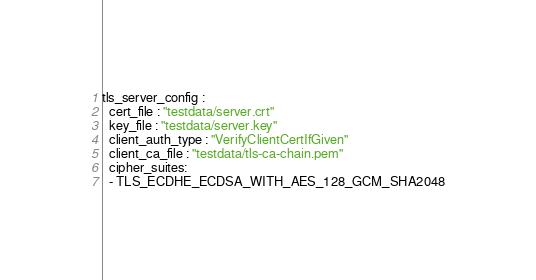<code> <loc_0><loc_0><loc_500><loc_500><_YAML_>tls_server_config :
  cert_file : "testdata/server.crt"
  key_file : "testdata/server.key"
  client_auth_type : "VerifyClientCertIfGiven"
  client_ca_file : "testdata/tls-ca-chain.pem"
  cipher_suites:
  - TLS_ECDHE_ECDSA_WITH_AES_128_GCM_SHA2048

</code> 